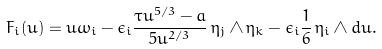<formula> <loc_0><loc_0><loc_500><loc_500>F _ { i } ( u ) = u \omega _ { i } - \epsilon _ { i } \frac { \tau u ^ { 5 / 3 } - a } { 5 u ^ { 2 / 3 } } \, \eta _ { j } \wedge \eta _ { k } - \epsilon _ { i } \frac { 1 } { 6 } \, \eta _ { i } \wedge d u .</formula> 